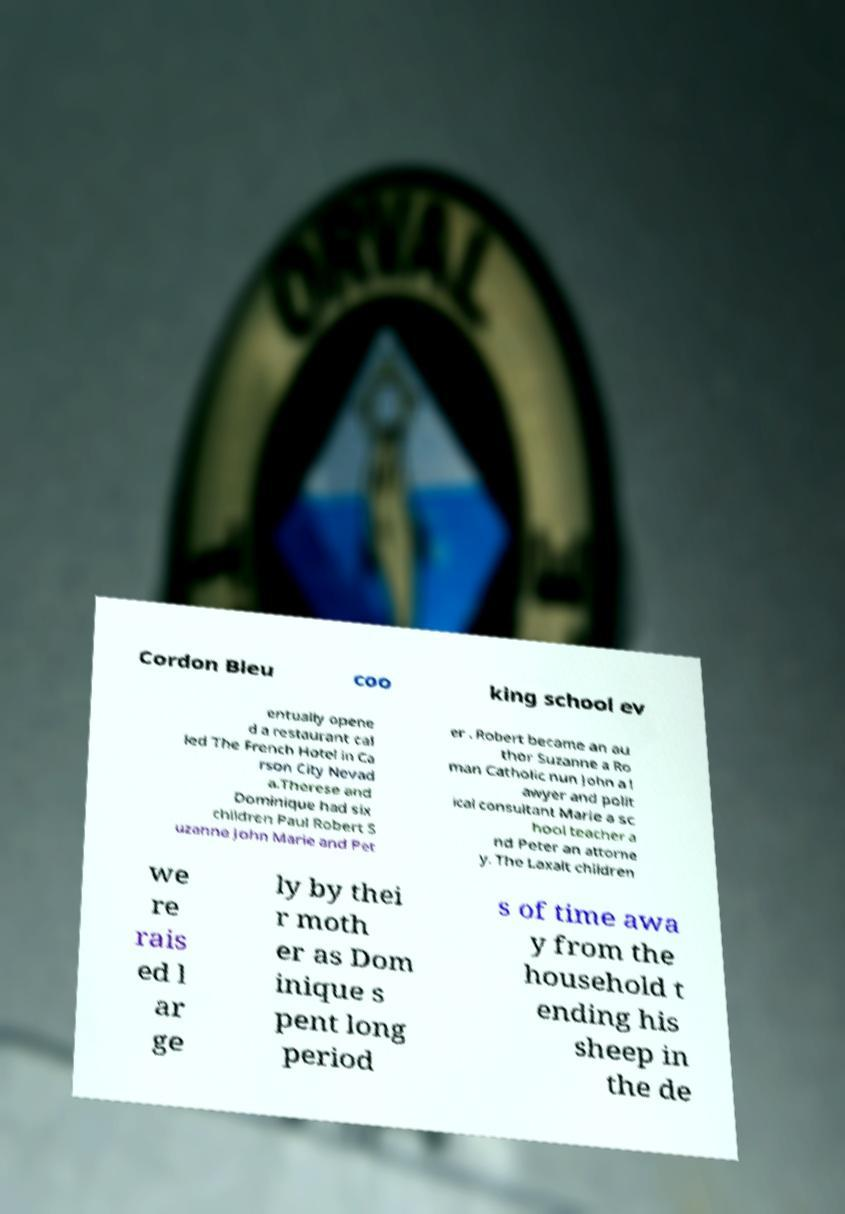Could you assist in decoding the text presented in this image and type it out clearly? Cordon Bleu coo king school ev entually opene d a restaurant cal led The French Hotel in Ca rson City Nevad a.Therese and Dominique had six children Paul Robert S uzanne John Marie and Pet er . Robert became an au thor Suzanne a Ro man Catholic nun John a l awyer and polit ical consultant Marie a sc hool teacher a nd Peter an attorne y. The Laxalt children we re rais ed l ar ge ly by thei r moth er as Dom inique s pent long period s of time awa y from the household t ending his sheep in the de 